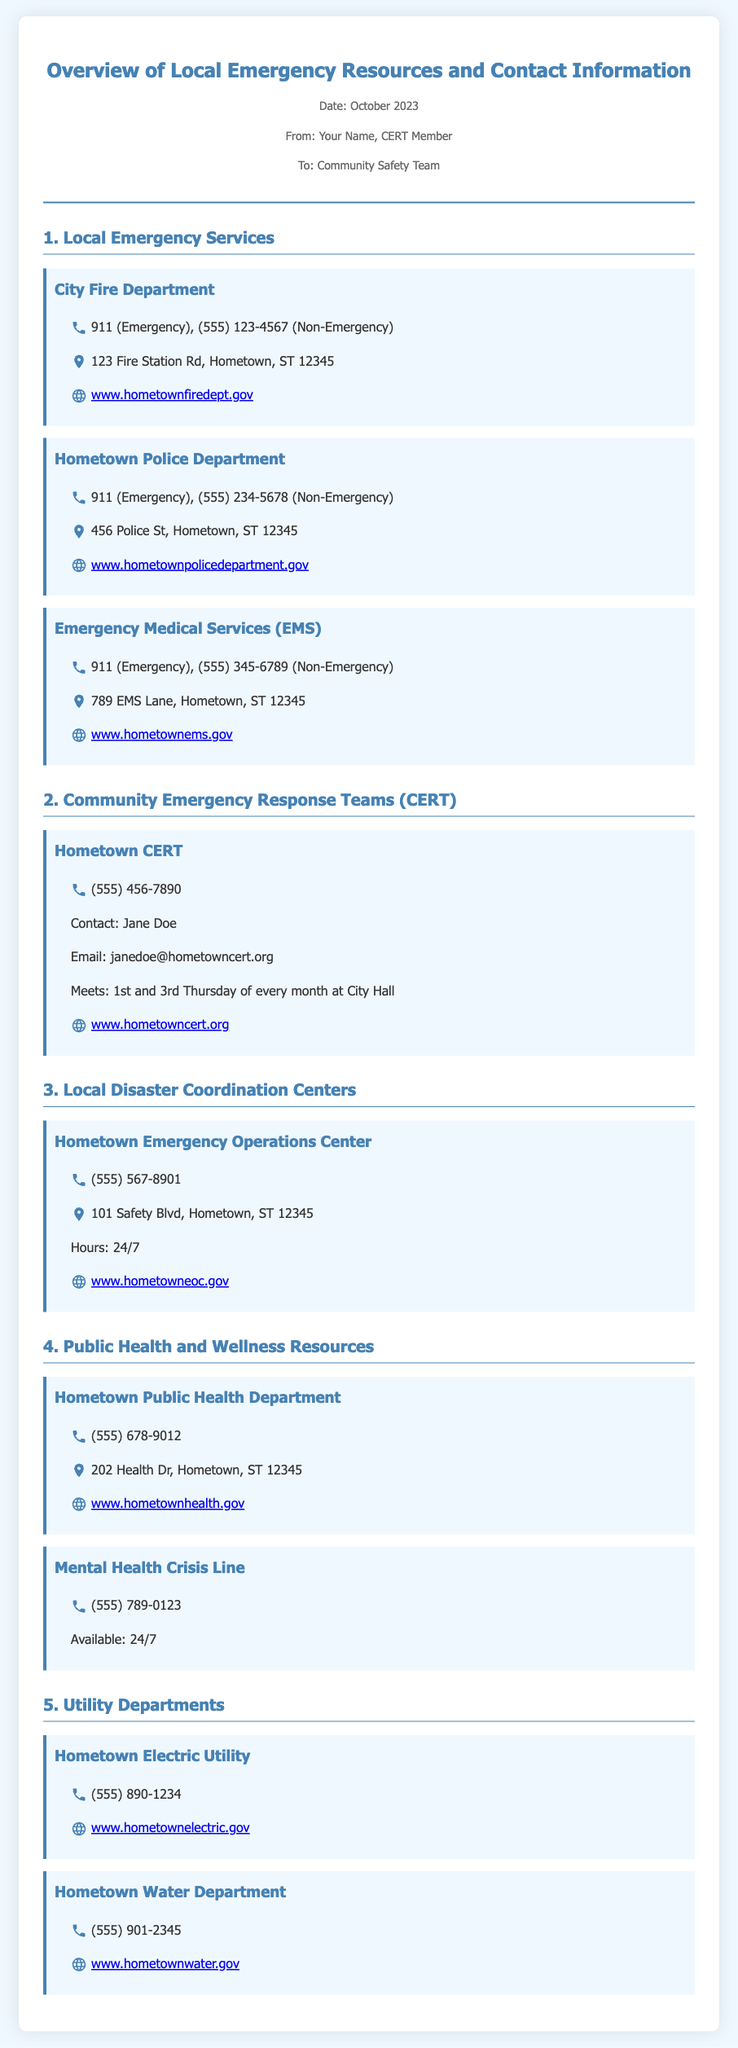what is the phone number for the City Fire Department's non-emergency line? The non-emergency phone number for the City Fire Department is listed in the document.
Answer: (555) 123-4567 where is the Hometown Police Department located? The address of the Hometown Police Department is provided in the document.
Answer: 456 Police St, Hometown, ST 12345 who is the contact person for Hometown CERT? The document includes the contact person for Hometown CERT.
Answer: Jane Doe what are the hours of the Hometown Emergency Operations Center? The operating hours for the Emergency Operations Center are specified in the document.
Answer: 24/7 which department has a crisis line available 24/7? The document mentions the Mental Health Crisis Line having availability around the clock.
Answer: Mental Health Crisis Line how often does Hometown CERT meet? The meeting frequency for Hometown CERT is stated in the document.
Answer: 1st and 3rd Thursday of every month what is the website for Hometown EMS? The document provides a URL for Hometown EMS.
Answer: www.hometownems.gov what type of services does the Hometown Public Health Department provide? The document describes the Hometown Public Health Department's function in relation to public health.
Answer: Public Health and Wellness Resources 